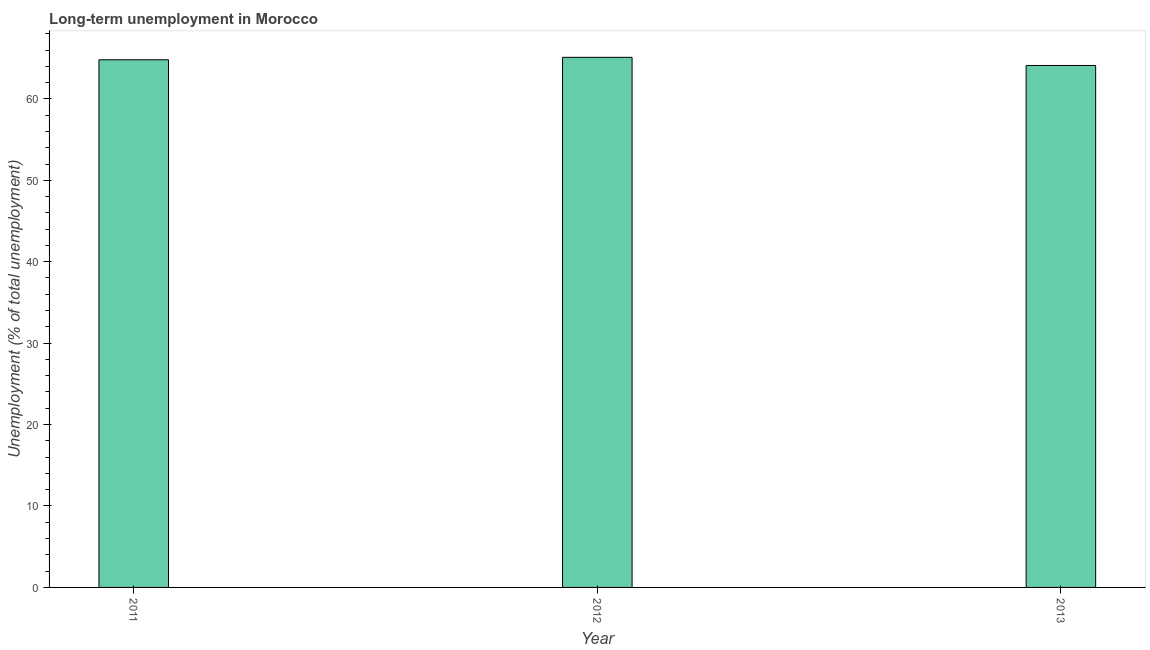What is the title of the graph?
Your answer should be compact. Long-term unemployment in Morocco. What is the label or title of the X-axis?
Your response must be concise. Year. What is the label or title of the Y-axis?
Make the answer very short. Unemployment (% of total unemployment). What is the long-term unemployment in 2012?
Make the answer very short. 65.1. Across all years, what is the maximum long-term unemployment?
Your response must be concise. 65.1. Across all years, what is the minimum long-term unemployment?
Provide a succinct answer. 64.1. In which year was the long-term unemployment maximum?
Offer a terse response. 2012. What is the sum of the long-term unemployment?
Offer a terse response. 194. What is the difference between the long-term unemployment in 2012 and 2013?
Keep it short and to the point. 1. What is the average long-term unemployment per year?
Make the answer very short. 64.67. What is the median long-term unemployment?
Offer a terse response. 64.8. What is the difference between the highest and the second highest long-term unemployment?
Your response must be concise. 0.3. Are all the bars in the graph horizontal?
Provide a succinct answer. No. How many years are there in the graph?
Your response must be concise. 3. What is the Unemployment (% of total unemployment) in 2011?
Your answer should be very brief. 64.8. What is the Unemployment (% of total unemployment) in 2012?
Your answer should be very brief. 65.1. What is the Unemployment (% of total unemployment) of 2013?
Offer a terse response. 64.1. What is the difference between the Unemployment (% of total unemployment) in 2011 and 2013?
Keep it short and to the point. 0.7. What is the ratio of the Unemployment (% of total unemployment) in 2011 to that in 2012?
Provide a short and direct response. 0.99. 